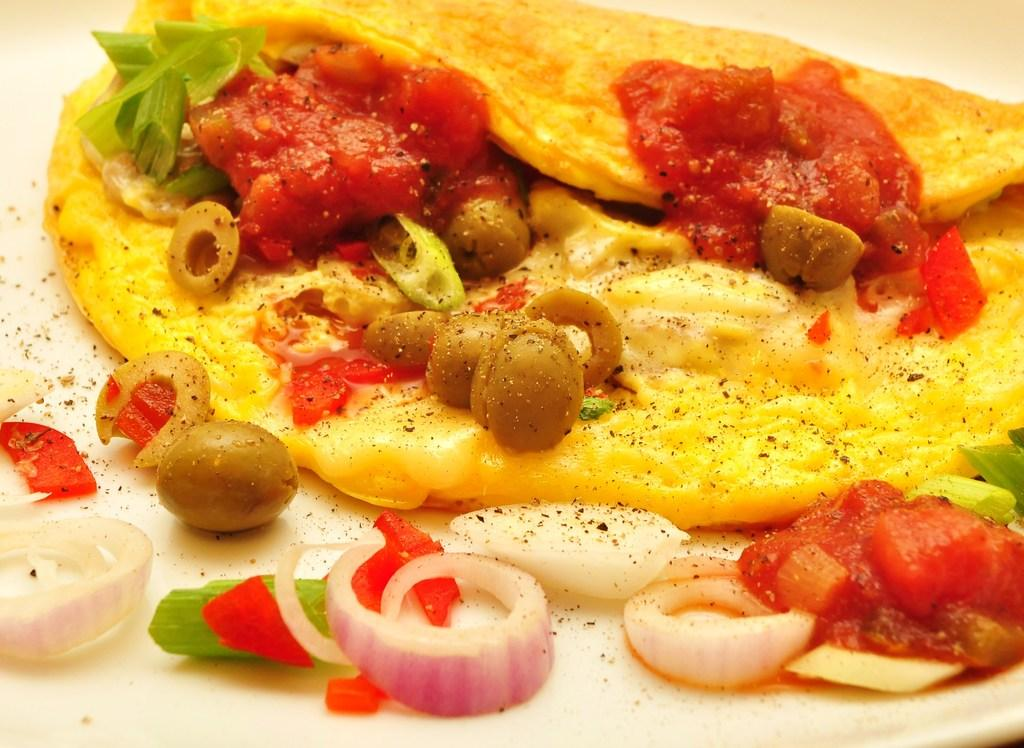What type of food can be seen in the image? There is food in the image, but the specific type is not mentioned. What specific ingredient is present on the plate? Onions are present on the plate in the image. How are the food and onions arranged in the image? The food and onions are placed on a plate. Where is the plate located in the image? The plate is in the center of the image. What type of cow can be seen in the image? There is no cow present in the image; it features food and onions on a plate. 